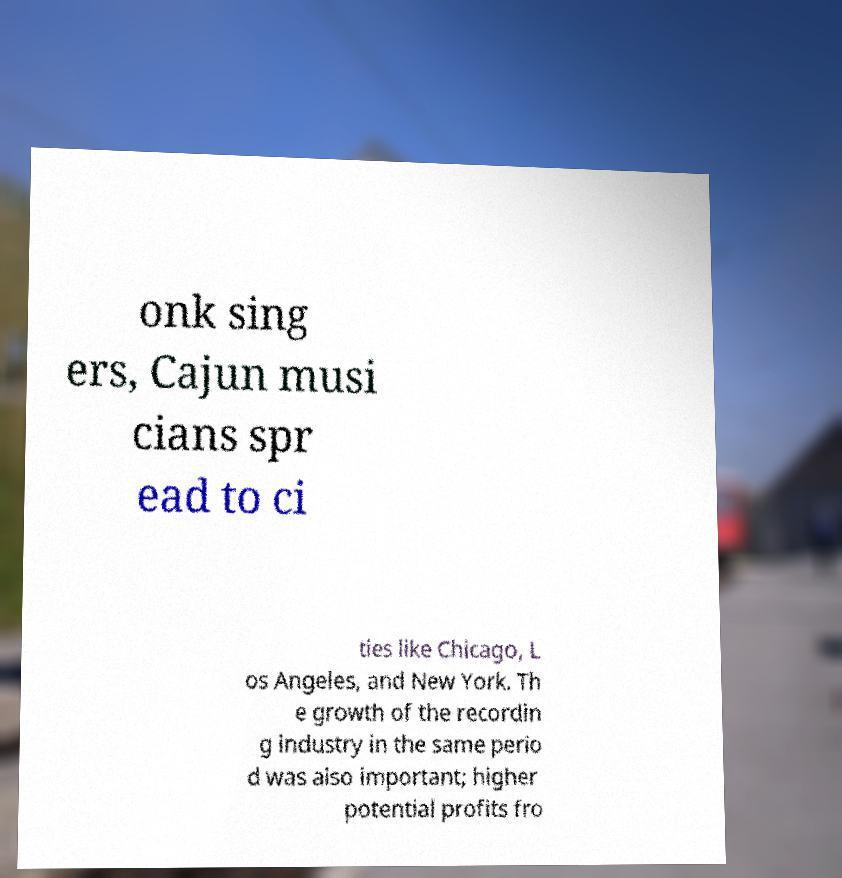There's text embedded in this image that I need extracted. Can you transcribe it verbatim? onk sing ers, Cajun musi cians spr ead to ci ties like Chicago, L os Angeles, and New York. Th e growth of the recordin g industry in the same perio d was also important; higher potential profits fro 